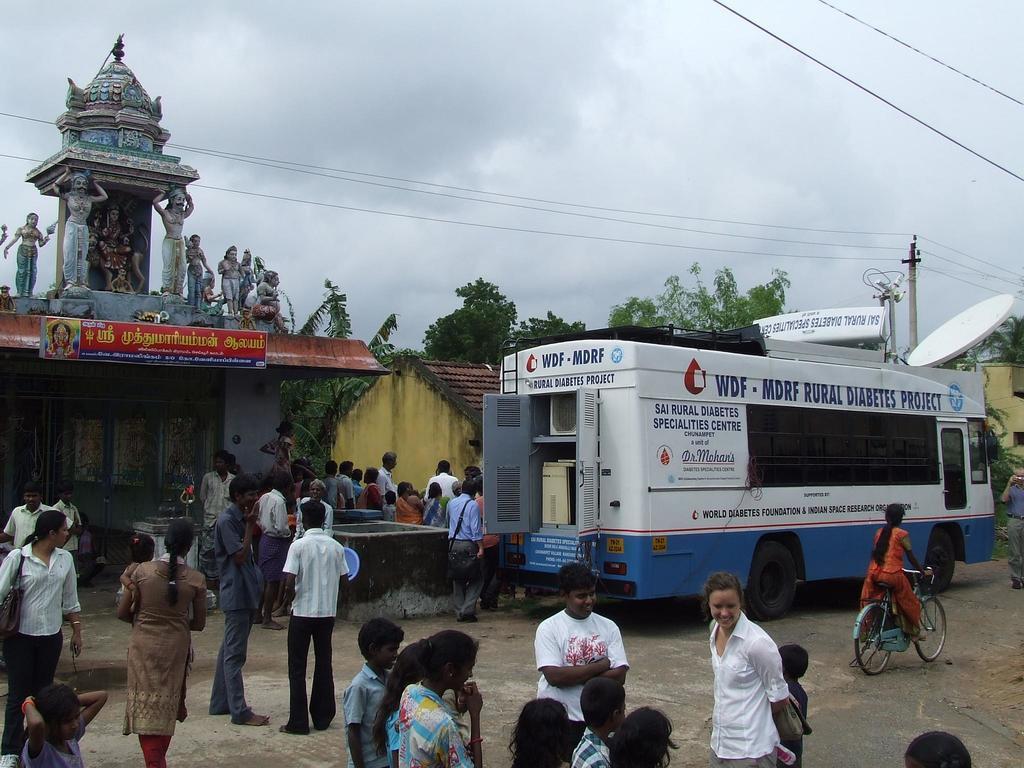Describe this image in one or two sentences. Here we can see group of people and a vehicle on the road. There is a girl riding a bicycle. Here we can see trees, poles, houses, and ancient architecture. There are boards. In the background there is sky. 